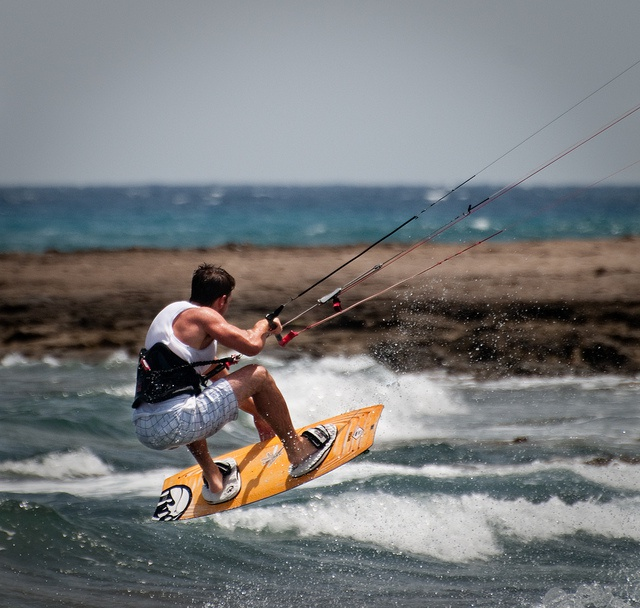Describe the objects in this image and their specific colors. I can see people in gray, black, maroon, and lightgray tones and surfboard in gray, orange, lightgray, and brown tones in this image. 